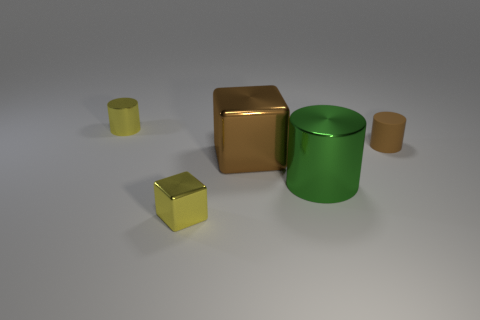Is there a gray metal thing?
Offer a terse response. No. Is there a brown thing behind the object that is to the left of the small yellow metal thing in front of the yellow metallic cylinder?
Offer a very short reply. No. Is there anything else that has the same size as the brown cylinder?
Your answer should be very brief. Yes. Do the brown rubber thing and the object that is behind the matte object have the same shape?
Give a very brief answer. Yes. What color is the metal cylinder that is to the right of the yellow metallic object behind the tiny yellow shiny object in front of the small brown cylinder?
Provide a succinct answer. Green. What number of things are either small cylinders to the left of the small matte thing or shiny objects that are behind the brown block?
Provide a succinct answer. 1. How many other objects are the same color as the rubber thing?
Your answer should be very brief. 1. Do the tiny metallic object in front of the small brown cylinder and the large brown metal thing have the same shape?
Make the answer very short. Yes. Is the number of rubber cylinders that are on the right side of the brown rubber object less than the number of purple spheres?
Give a very brief answer. No. Are there any gray cubes made of the same material as the small yellow cylinder?
Your response must be concise. No. 